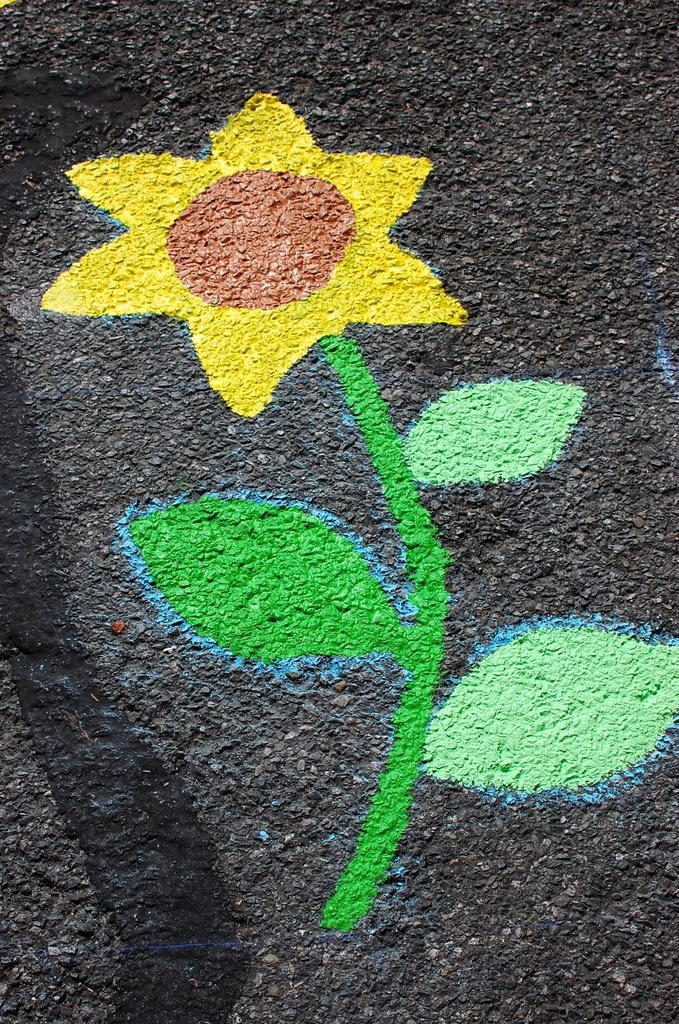What is depicted in the image? There is a painting in the image. What is the subject of the painting? The painting is of a flower. Where is the painting located? The painting is on the road. What colors are used in the painting? The painting has yellow, green, and red colors. What is the background color of the painting? The background of the painting is black. What type of flesh can be seen in the painting? There is no flesh present in the painting, as it is a painting of a flower. How does the rose in the painting show respect to the viewer? There is no rose in the painting, and the concept of respect is not applicable to a painting of a flower. 